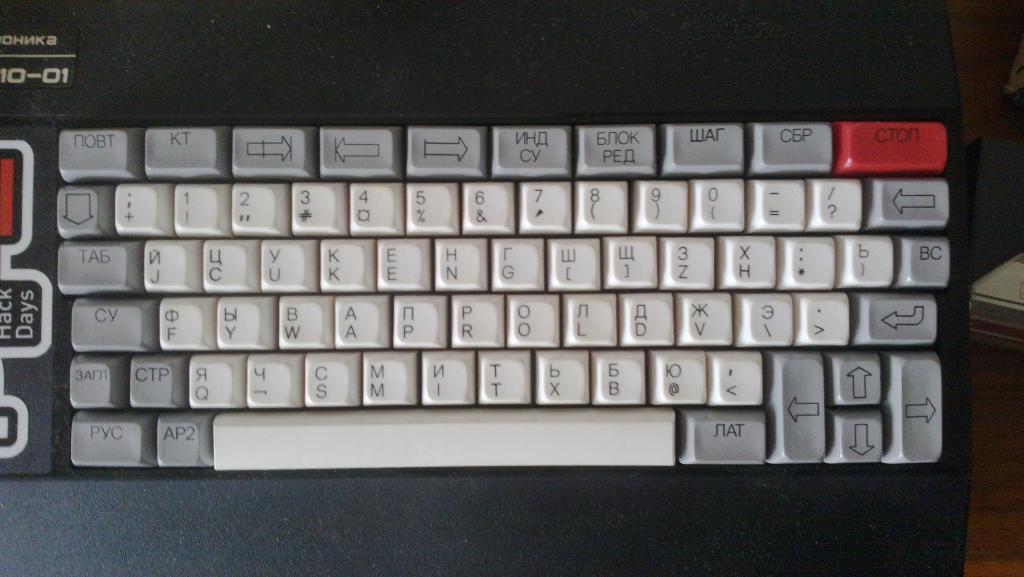What key is to the left of space bar?
Offer a terse response. Ap2. 